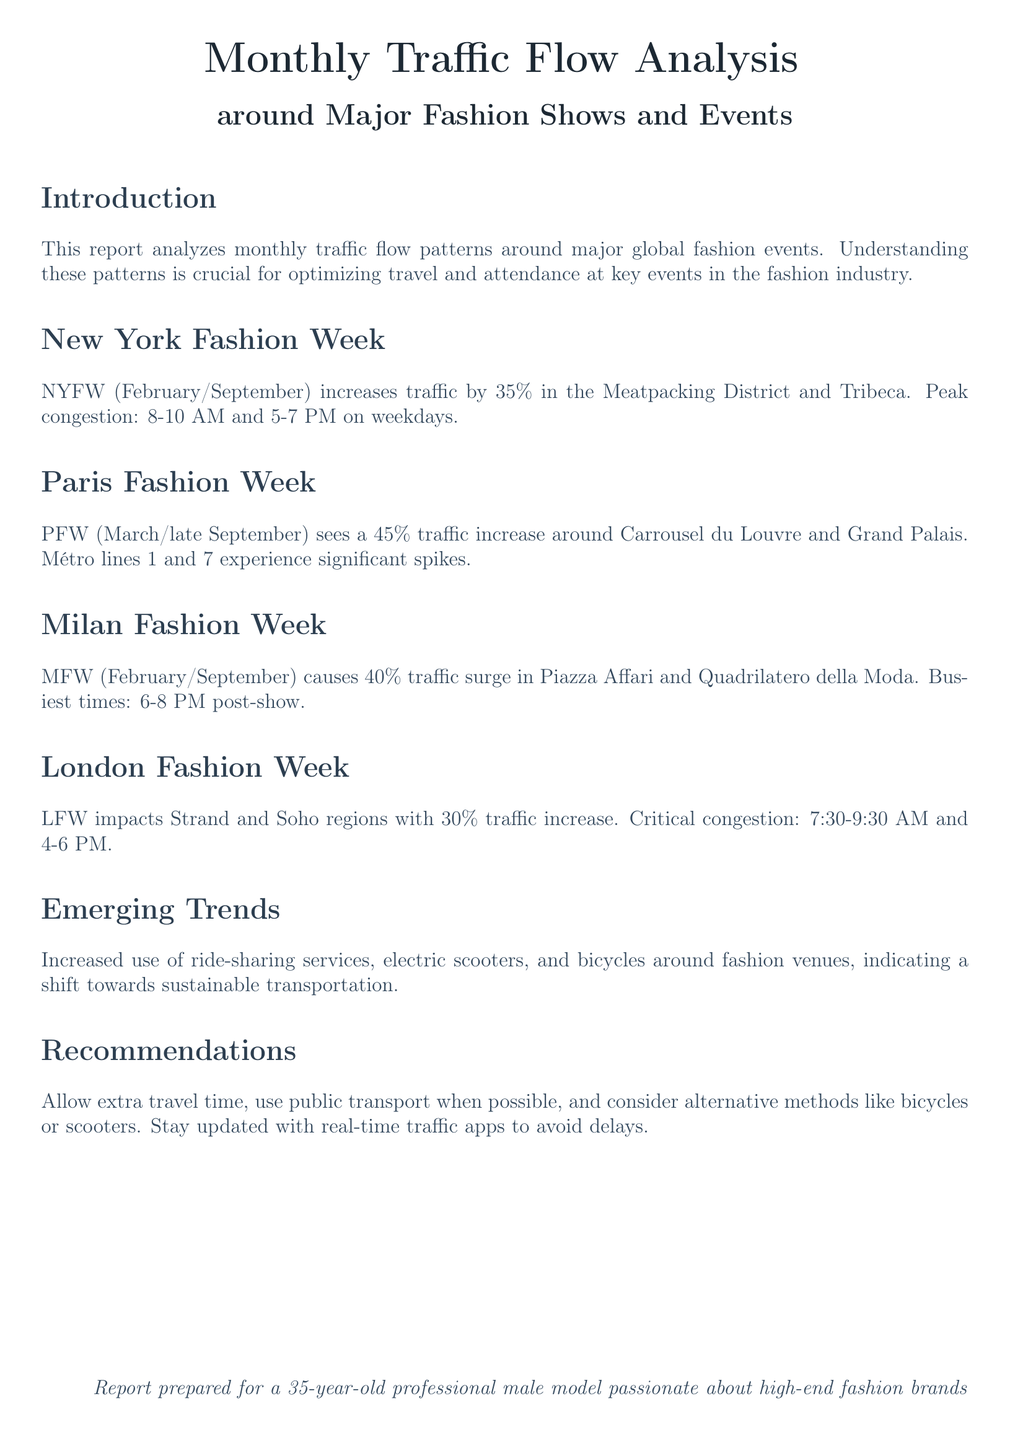what is the traffic increase percentage during New York Fashion Week? The document states that NYFW increases traffic by 35% in the specified districts.
Answer: 35% what is the busiest time post-show during Milan Fashion Week? According to the report, the busiest times are between 6-8 PM after the shows conclude.
Answer: 6-8 PM which metro lines experience significant spikes during Paris Fashion Week? The report mentions that Métro lines 1 and 7 see significant traffic spikes.
Answer: lines 1 and 7 what is the traffic increase percentage during London Fashion Week? The document specifies that LFW impacts the area with a 30% increase in traffic.
Answer: 30% what shift in transportation trends is noted in the report? The report highlights a shift towards sustainable transportation methods like ride-sharing, electric scooters, and bicycles.
Answer: sustainable transportation what is the critical congestion time for New York Fashion Week? The document states that critical congestion occurs from 8-10 AM and 5-7 PM on weekdays.
Answer: 8-10 AM and 5-7 PM during which months does Milan Fashion Week occur? The report indicates that MFW takes place in February and September.
Answer: February and September what are the recommended alternatives to avoid travel delays? The document suggests using public transport, bicycles, or scooters as alternatives.
Answer: public transport, bicycles, scooters 